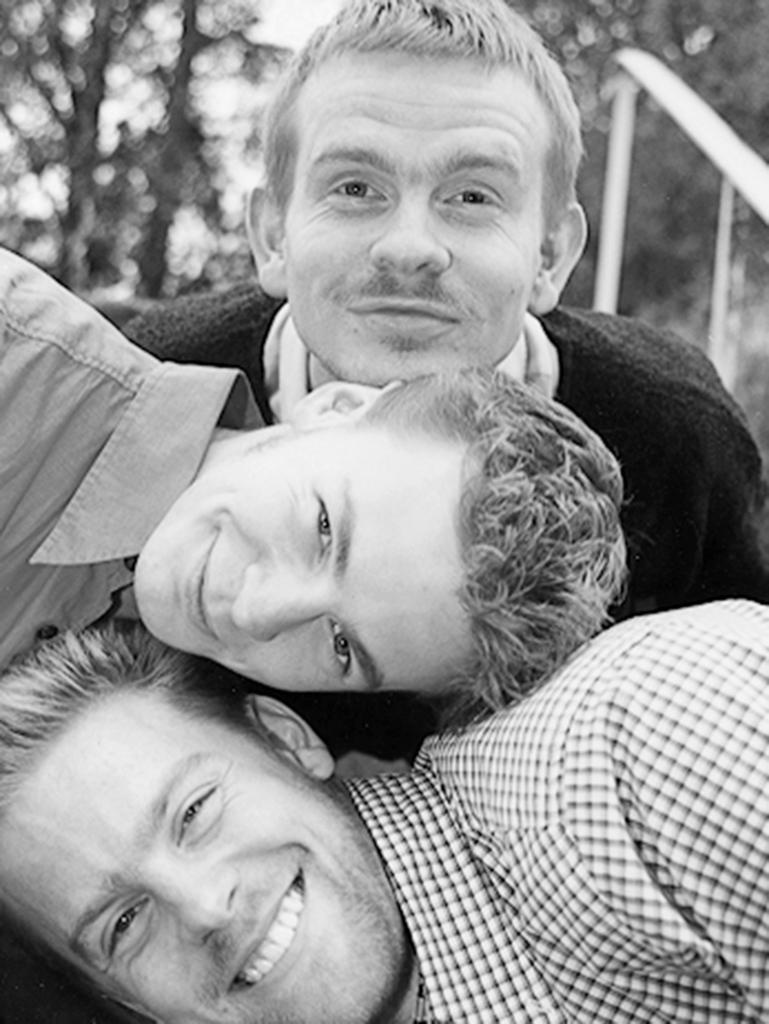What is the color scheme of the image? The image is black and white. How many people are in the image? There are three men in the image. What is the facial expression of the men in the image? The men are smiling. Can you describe the background of the image? The background appears blurry. What type of dirt can be seen on the men's shoes in the image? There is no dirt visible on the men's shoes in the image, as it is a black and white image and dirt would not be discernible. 